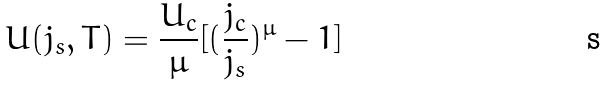<formula> <loc_0><loc_0><loc_500><loc_500>U ( j _ { s } , T ) = \frac { U _ { c } } { \mu } [ ( \frac { j _ { c } } { j _ { s } } ) ^ { \mu } - 1 ]</formula> 